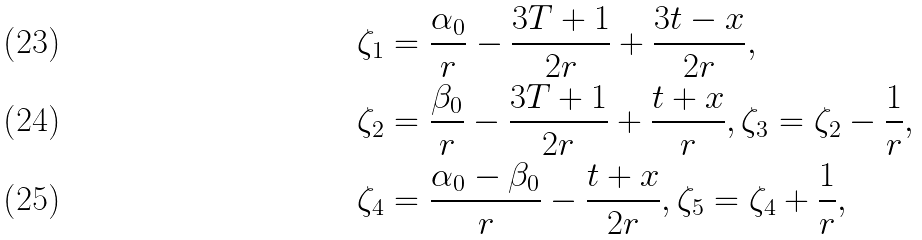Convert formula to latex. <formula><loc_0><loc_0><loc_500><loc_500>\zeta _ { 1 } & = \frac { \alpha _ { 0 } } { r } - \frac { 3 T + 1 } { 2 r } + \frac { 3 t - x } { 2 r } , \\ \zeta _ { 2 } & = \frac { \beta _ { 0 } } { r } - \frac { 3 T + 1 } { 2 r } + \frac { t + x } { r } , \zeta _ { 3 } = \zeta _ { 2 } - \frac { 1 } { r } , \\ \zeta _ { 4 } & = \frac { \alpha _ { 0 } - \beta _ { 0 } } { r } - \frac { t + x } { 2 r } , \zeta _ { 5 } = \zeta _ { 4 } + \frac { 1 } { r } ,</formula> 